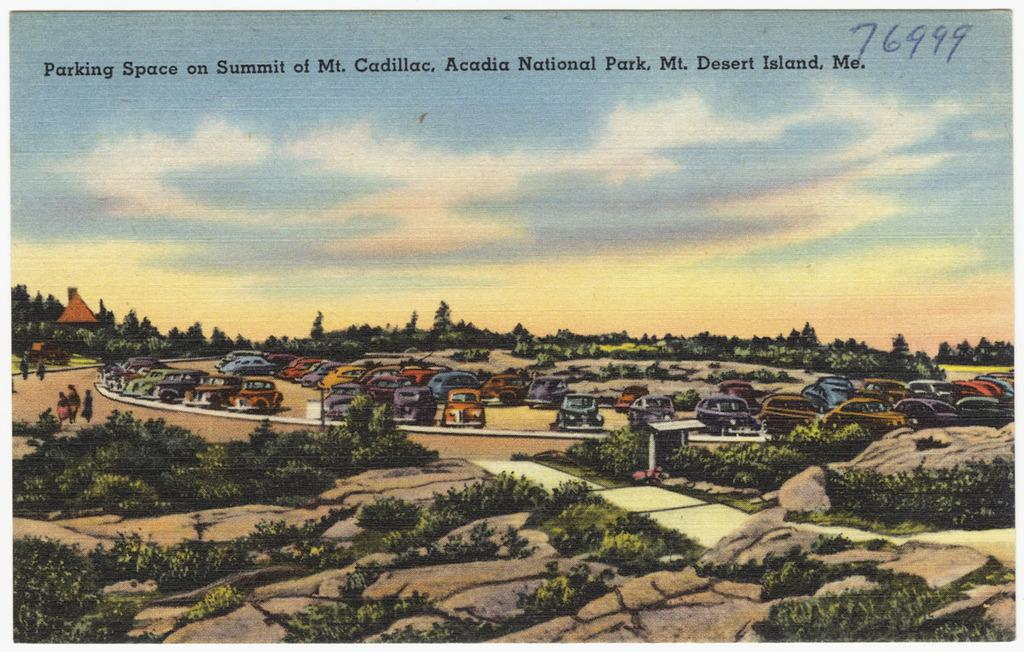Provide a one-sentence caption for the provided image. Postcard from the parking space on Summit of Mt Cadillac in Acadia National Park. 